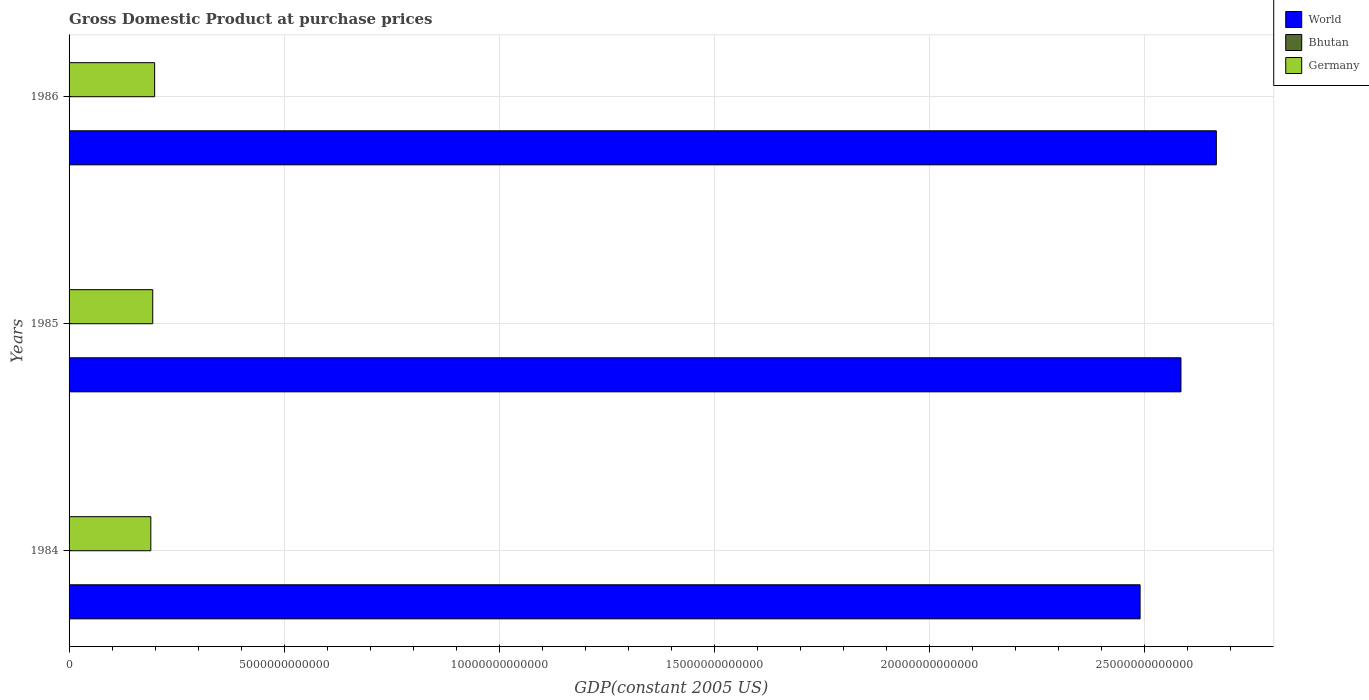How many groups of bars are there?
Your response must be concise. 3. Are the number of bars per tick equal to the number of legend labels?
Keep it short and to the point. Yes. Are the number of bars on each tick of the Y-axis equal?
Keep it short and to the point. Yes. How many bars are there on the 1st tick from the bottom?
Offer a very short reply. 3. In how many cases, is the number of bars for a given year not equal to the number of legend labels?
Your answer should be compact. 0. What is the GDP at purchase prices in Bhutan in 1986?
Ensure brevity in your answer.  2.14e+08. Across all years, what is the maximum GDP at purchase prices in Germany?
Ensure brevity in your answer.  1.99e+12. Across all years, what is the minimum GDP at purchase prices in Bhutan?
Your response must be concise. 1.84e+08. In which year was the GDP at purchase prices in World minimum?
Your answer should be very brief. 1984. What is the total GDP at purchase prices in Bhutan in the graph?
Keep it short and to the point. 5.90e+08. What is the difference between the GDP at purchase prices in Bhutan in 1984 and that in 1985?
Provide a succinct answer. -7.74e+06. What is the difference between the GDP at purchase prices in World in 1984 and the GDP at purchase prices in Bhutan in 1986?
Ensure brevity in your answer.  2.49e+13. What is the average GDP at purchase prices in Germany per year?
Provide a short and direct response. 1.94e+12. In the year 1985, what is the difference between the GDP at purchase prices in Germany and GDP at purchase prices in World?
Provide a short and direct response. -2.39e+13. In how many years, is the GDP at purchase prices in World greater than 8000000000000 US$?
Your response must be concise. 3. What is the ratio of the GDP at purchase prices in World in 1985 to that in 1986?
Give a very brief answer. 0.97. Is the GDP at purchase prices in Bhutan in 1985 less than that in 1986?
Offer a very short reply. Yes. Is the difference between the GDP at purchase prices in Germany in 1984 and 1985 greater than the difference between the GDP at purchase prices in World in 1984 and 1985?
Ensure brevity in your answer.  Yes. What is the difference between the highest and the second highest GDP at purchase prices in Bhutan?
Provide a short and direct response. 2.25e+07. What is the difference between the highest and the lowest GDP at purchase prices in Germany?
Keep it short and to the point. 8.87e+1. In how many years, is the GDP at purchase prices in World greater than the average GDP at purchase prices in World taken over all years?
Make the answer very short. 2. Is the sum of the GDP at purchase prices in Bhutan in 1984 and 1985 greater than the maximum GDP at purchase prices in World across all years?
Your answer should be very brief. No. What does the 2nd bar from the top in 1985 represents?
Give a very brief answer. Bhutan. What does the 2nd bar from the bottom in 1984 represents?
Make the answer very short. Bhutan. Is it the case that in every year, the sum of the GDP at purchase prices in Germany and GDP at purchase prices in World is greater than the GDP at purchase prices in Bhutan?
Your answer should be very brief. Yes. How many bars are there?
Provide a succinct answer. 9. How many years are there in the graph?
Give a very brief answer. 3. What is the difference between two consecutive major ticks on the X-axis?
Offer a very short reply. 5.00e+12. Are the values on the major ticks of X-axis written in scientific E-notation?
Offer a very short reply. No. Does the graph contain grids?
Ensure brevity in your answer.  Yes. What is the title of the graph?
Your response must be concise. Gross Domestic Product at purchase prices. Does "Fiji" appear as one of the legend labels in the graph?
Offer a very short reply. No. What is the label or title of the X-axis?
Provide a succinct answer. GDP(constant 2005 US). What is the GDP(constant 2005 US) in World in 1984?
Your answer should be compact. 2.49e+13. What is the GDP(constant 2005 US) in Bhutan in 1984?
Make the answer very short. 1.84e+08. What is the GDP(constant 2005 US) of Germany in 1984?
Your answer should be very brief. 1.90e+12. What is the GDP(constant 2005 US) of World in 1985?
Your answer should be compact. 2.58e+13. What is the GDP(constant 2005 US) in Bhutan in 1985?
Your answer should be very brief. 1.92e+08. What is the GDP(constant 2005 US) of Germany in 1985?
Keep it short and to the point. 1.94e+12. What is the GDP(constant 2005 US) in World in 1986?
Keep it short and to the point. 2.67e+13. What is the GDP(constant 2005 US) of Bhutan in 1986?
Your answer should be very brief. 2.14e+08. What is the GDP(constant 2005 US) of Germany in 1986?
Keep it short and to the point. 1.99e+12. Across all years, what is the maximum GDP(constant 2005 US) of World?
Offer a terse response. 2.67e+13. Across all years, what is the maximum GDP(constant 2005 US) of Bhutan?
Ensure brevity in your answer.  2.14e+08. Across all years, what is the maximum GDP(constant 2005 US) in Germany?
Offer a very short reply. 1.99e+12. Across all years, what is the minimum GDP(constant 2005 US) in World?
Ensure brevity in your answer.  2.49e+13. Across all years, what is the minimum GDP(constant 2005 US) in Bhutan?
Your answer should be very brief. 1.84e+08. Across all years, what is the minimum GDP(constant 2005 US) of Germany?
Offer a terse response. 1.90e+12. What is the total GDP(constant 2005 US) in World in the graph?
Your answer should be compact. 7.74e+13. What is the total GDP(constant 2005 US) in Bhutan in the graph?
Ensure brevity in your answer.  5.90e+08. What is the total GDP(constant 2005 US) of Germany in the graph?
Offer a terse response. 5.83e+12. What is the difference between the GDP(constant 2005 US) of World in 1984 and that in 1985?
Make the answer very short. -9.49e+11. What is the difference between the GDP(constant 2005 US) of Bhutan in 1984 and that in 1985?
Your answer should be compact. -7.74e+06. What is the difference between the GDP(constant 2005 US) of Germany in 1984 and that in 1985?
Offer a very short reply. -4.42e+1. What is the difference between the GDP(constant 2005 US) of World in 1984 and that in 1986?
Provide a succinct answer. -1.77e+12. What is the difference between the GDP(constant 2005 US) in Bhutan in 1984 and that in 1986?
Make the answer very short. -3.02e+07. What is the difference between the GDP(constant 2005 US) in Germany in 1984 and that in 1986?
Your answer should be compact. -8.87e+1. What is the difference between the GDP(constant 2005 US) of World in 1985 and that in 1986?
Provide a succinct answer. -8.23e+11. What is the difference between the GDP(constant 2005 US) in Bhutan in 1985 and that in 1986?
Your answer should be compact. -2.25e+07. What is the difference between the GDP(constant 2005 US) in Germany in 1985 and that in 1986?
Make the answer very short. -4.45e+1. What is the difference between the GDP(constant 2005 US) in World in 1984 and the GDP(constant 2005 US) in Bhutan in 1985?
Give a very brief answer. 2.49e+13. What is the difference between the GDP(constant 2005 US) of World in 1984 and the GDP(constant 2005 US) of Germany in 1985?
Offer a terse response. 2.29e+13. What is the difference between the GDP(constant 2005 US) in Bhutan in 1984 and the GDP(constant 2005 US) in Germany in 1985?
Provide a short and direct response. -1.94e+12. What is the difference between the GDP(constant 2005 US) of World in 1984 and the GDP(constant 2005 US) of Bhutan in 1986?
Your response must be concise. 2.49e+13. What is the difference between the GDP(constant 2005 US) in World in 1984 and the GDP(constant 2005 US) in Germany in 1986?
Your response must be concise. 2.29e+13. What is the difference between the GDP(constant 2005 US) in Bhutan in 1984 and the GDP(constant 2005 US) in Germany in 1986?
Your response must be concise. -1.99e+12. What is the difference between the GDP(constant 2005 US) in World in 1985 and the GDP(constant 2005 US) in Bhutan in 1986?
Provide a short and direct response. 2.58e+13. What is the difference between the GDP(constant 2005 US) of World in 1985 and the GDP(constant 2005 US) of Germany in 1986?
Make the answer very short. 2.39e+13. What is the difference between the GDP(constant 2005 US) of Bhutan in 1985 and the GDP(constant 2005 US) of Germany in 1986?
Your response must be concise. -1.99e+12. What is the average GDP(constant 2005 US) in World per year?
Give a very brief answer. 2.58e+13. What is the average GDP(constant 2005 US) of Bhutan per year?
Keep it short and to the point. 1.97e+08. What is the average GDP(constant 2005 US) in Germany per year?
Keep it short and to the point. 1.94e+12. In the year 1984, what is the difference between the GDP(constant 2005 US) in World and GDP(constant 2005 US) in Bhutan?
Ensure brevity in your answer.  2.49e+13. In the year 1984, what is the difference between the GDP(constant 2005 US) in World and GDP(constant 2005 US) in Germany?
Make the answer very short. 2.30e+13. In the year 1984, what is the difference between the GDP(constant 2005 US) in Bhutan and GDP(constant 2005 US) in Germany?
Ensure brevity in your answer.  -1.90e+12. In the year 1985, what is the difference between the GDP(constant 2005 US) of World and GDP(constant 2005 US) of Bhutan?
Offer a very short reply. 2.58e+13. In the year 1985, what is the difference between the GDP(constant 2005 US) in World and GDP(constant 2005 US) in Germany?
Keep it short and to the point. 2.39e+13. In the year 1985, what is the difference between the GDP(constant 2005 US) in Bhutan and GDP(constant 2005 US) in Germany?
Provide a short and direct response. -1.94e+12. In the year 1986, what is the difference between the GDP(constant 2005 US) in World and GDP(constant 2005 US) in Bhutan?
Provide a short and direct response. 2.67e+13. In the year 1986, what is the difference between the GDP(constant 2005 US) of World and GDP(constant 2005 US) of Germany?
Provide a succinct answer. 2.47e+13. In the year 1986, what is the difference between the GDP(constant 2005 US) of Bhutan and GDP(constant 2005 US) of Germany?
Your response must be concise. -1.99e+12. What is the ratio of the GDP(constant 2005 US) in World in 1984 to that in 1985?
Your response must be concise. 0.96. What is the ratio of the GDP(constant 2005 US) of Bhutan in 1984 to that in 1985?
Give a very brief answer. 0.96. What is the ratio of the GDP(constant 2005 US) in Germany in 1984 to that in 1985?
Provide a succinct answer. 0.98. What is the ratio of the GDP(constant 2005 US) in World in 1984 to that in 1986?
Keep it short and to the point. 0.93. What is the ratio of the GDP(constant 2005 US) in Bhutan in 1984 to that in 1986?
Your response must be concise. 0.86. What is the ratio of the GDP(constant 2005 US) in Germany in 1984 to that in 1986?
Offer a very short reply. 0.96. What is the ratio of the GDP(constant 2005 US) in World in 1985 to that in 1986?
Your answer should be very brief. 0.97. What is the ratio of the GDP(constant 2005 US) in Bhutan in 1985 to that in 1986?
Make the answer very short. 0.9. What is the ratio of the GDP(constant 2005 US) in Germany in 1985 to that in 1986?
Your answer should be very brief. 0.98. What is the difference between the highest and the second highest GDP(constant 2005 US) of World?
Provide a short and direct response. 8.23e+11. What is the difference between the highest and the second highest GDP(constant 2005 US) in Bhutan?
Make the answer very short. 2.25e+07. What is the difference between the highest and the second highest GDP(constant 2005 US) of Germany?
Your answer should be very brief. 4.45e+1. What is the difference between the highest and the lowest GDP(constant 2005 US) of World?
Offer a very short reply. 1.77e+12. What is the difference between the highest and the lowest GDP(constant 2005 US) of Bhutan?
Your answer should be compact. 3.02e+07. What is the difference between the highest and the lowest GDP(constant 2005 US) in Germany?
Keep it short and to the point. 8.87e+1. 